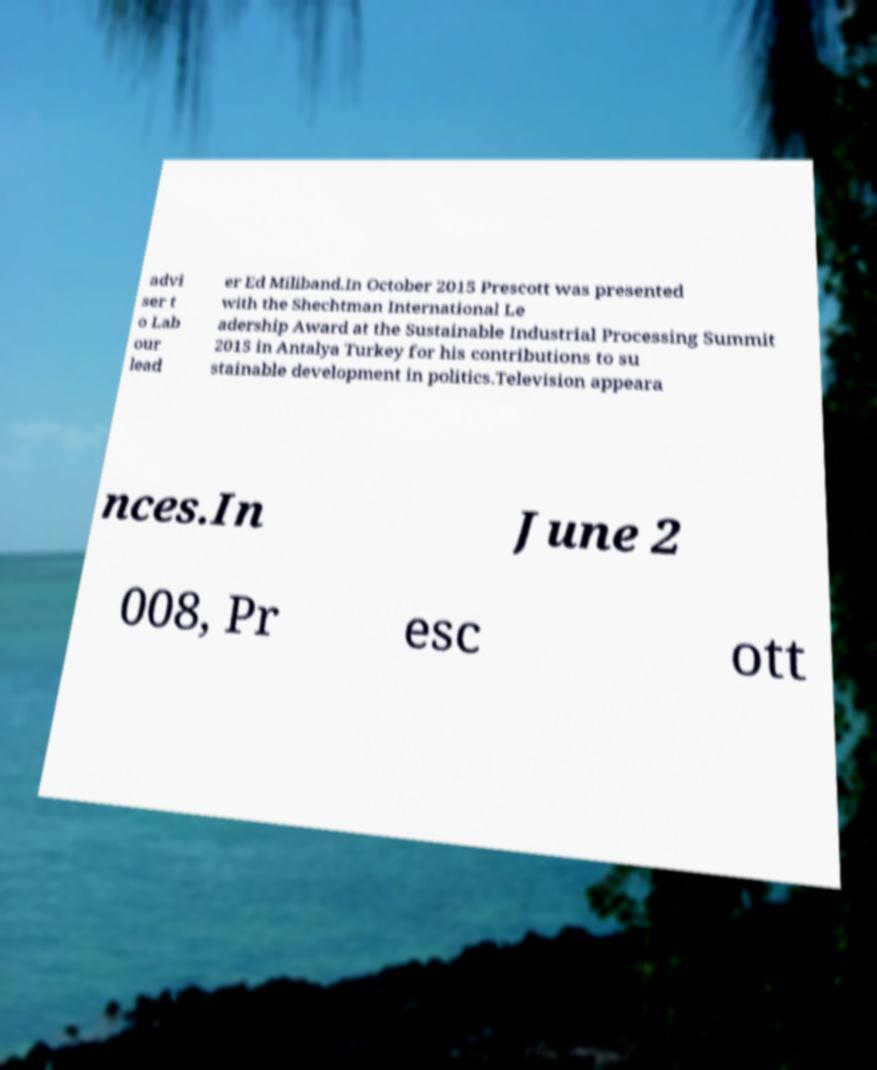For documentation purposes, I need the text within this image transcribed. Could you provide that? advi ser t o Lab our lead er Ed Miliband.In October 2015 Prescott was presented with the Shechtman International Le adership Award at the Sustainable Industrial Processing Summit 2015 in Antalya Turkey for his contributions to su stainable development in politics.Television appeara nces.In June 2 008, Pr esc ott 